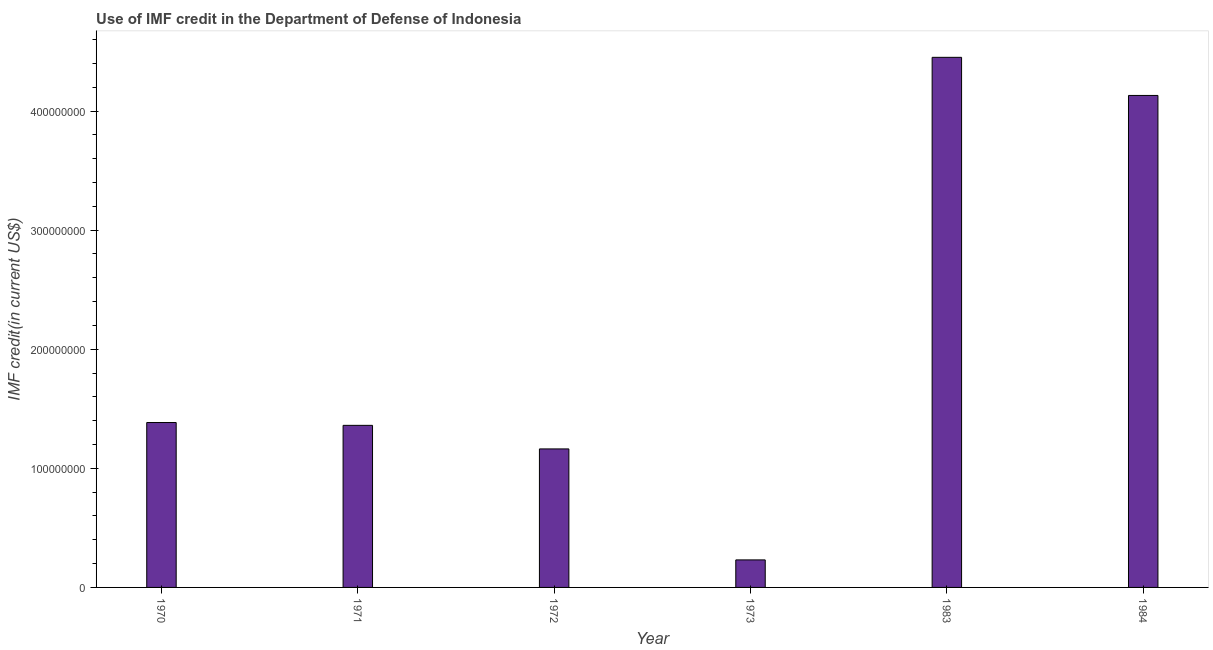Does the graph contain any zero values?
Your response must be concise. No. What is the title of the graph?
Your answer should be compact. Use of IMF credit in the Department of Defense of Indonesia. What is the label or title of the X-axis?
Your answer should be compact. Year. What is the label or title of the Y-axis?
Your answer should be very brief. IMF credit(in current US$). What is the use of imf credit in dod in 1970?
Make the answer very short. 1.38e+08. Across all years, what is the maximum use of imf credit in dod?
Make the answer very short. 4.45e+08. Across all years, what is the minimum use of imf credit in dod?
Provide a succinct answer. 2.31e+07. In which year was the use of imf credit in dod maximum?
Make the answer very short. 1983. In which year was the use of imf credit in dod minimum?
Offer a very short reply. 1973. What is the sum of the use of imf credit in dod?
Provide a succinct answer. 1.27e+09. What is the difference between the use of imf credit in dod in 1970 and 1983?
Make the answer very short. -3.07e+08. What is the average use of imf credit in dod per year?
Make the answer very short. 2.12e+08. What is the median use of imf credit in dod?
Provide a short and direct response. 1.37e+08. In how many years, is the use of imf credit in dod greater than 280000000 US$?
Make the answer very short. 2. What is the ratio of the use of imf credit in dod in 1971 to that in 1973?
Offer a terse response. 5.89. Is the use of imf credit in dod in 1970 less than that in 1971?
Provide a succinct answer. No. What is the difference between the highest and the second highest use of imf credit in dod?
Give a very brief answer. 3.20e+07. What is the difference between the highest and the lowest use of imf credit in dod?
Offer a terse response. 4.22e+08. How many bars are there?
Give a very brief answer. 6. What is the difference between two consecutive major ticks on the Y-axis?
Your answer should be compact. 1.00e+08. Are the values on the major ticks of Y-axis written in scientific E-notation?
Keep it short and to the point. No. What is the IMF credit(in current US$) of 1970?
Keep it short and to the point. 1.38e+08. What is the IMF credit(in current US$) in 1971?
Offer a very short reply. 1.36e+08. What is the IMF credit(in current US$) in 1972?
Offer a terse response. 1.16e+08. What is the IMF credit(in current US$) of 1973?
Your answer should be compact. 2.31e+07. What is the IMF credit(in current US$) of 1983?
Your answer should be compact. 4.45e+08. What is the IMF credit(in current US$) of 1984?
Give a very brief answer. 4.13e+08. What is the difference between the IMF credit(in current US$) in 1970 and 1971?
Ensure brevity in your answer.  2.37e+06. What is the difference between the IMF credit(in current US$) in 1970 and 1972?
Keep it short and to the point. 2.22e+07. What is the difference between the IMF credit(in current US$) in 1970 and 1973?
Offer a terse response. 1.15e+08. What is the difference between the IMF credit(in current US$) in 1970 and 1983?
Your answer should be very brief. -3.07e+08. What is the difference between the IMF credit(in current US$) in 1970 and 1984?
Your answer should be compact. -2.75e+08. What is the difference between the IMF credit(in current US$) in 1971 and 1972?
Keep it short and to the point. 1.98e+07. What is the difference between the IMF credit(in current US$) in 1971 and 1973?
Provide a succinct answer. 1.13e+08. What is the difference between the IMF credit(in current US$) in 1971 and 1983?
Your answer should be very brief. -3.09e+08. What is the difference between the IMF credit(in current US$) in 1971 and 1984?
Provide a short and direct response. -2.77e+08. What is the difference between the IMF credit(in current US$) in 1972 and 1973?
Your answer should be very brief. 9.32e+07. What is the difference between the IMF credit(in current US$) in 1972 and 1983?
Keep it short and to the point. -3.29e+08. What is the difference between the IMF credit(in current US$) in 1972 and 1984?
Offer a terse response. -2.97e+08. What is the difference between the IMF credit(in current US$) in 1973 and 1983?
Keep it short and to the point. -4.22e+08. What is the difference between the IMF credit(in current US$) in 1973 and 1984?
Offer a very short reply. -3.90e+08. What is the difference between the IMF credit(in current US$) in 1983 and 1984?
Give a very brief answer. 3.20e+07. What is the ratio of the IMF credit(in current US$) in 1970 to that in 1972?
Your answer should be very brief. 1.19. What is the ratio of the IMF credit(in current US$) in 1970 to that in 1973?
Your response must be concise. 5.99. What is the ratio of the IMF credit(in current US$) in 1970 to that in 1983?
Your answer should be compact. 0.31. What is the ratio of the IMF credit(in current US$) in 1970 to that in 1984?
Provide a succinct answer. 0.34. What is the ratio of the IMF credit(in current US$) in 1971 to that in 1972?
Your response must be concise. 1.17. What is the ratio of the IMF credit(in current US$) in 1971 to that in 1973?
Provide a short and direct response. 5.89. What is the ratio of the IMF credit(in current US$) in 1971 to that in 1983?
Offer a very short reply. 0.31. What is the ratio of the IMF credit(in current US$) in 1971 to that in 1984?
Ensure brevity in your answer.  0.33. What is the ratio of the IMF credit(in current US$) in 1972 to that in 1973?
Give a very brief answer. 5.03. What is the ratio of the IMF credit(in current US$) in 1972 to that in 1983?
Provide a short and direct response. 0.26. What is the ratio of the IMF credit(in current US$) in 1972 to that in 1984?
Offer a very short reply. 0.28. What is the ratio of the IMF credit(in current US$) in 1973 to that in 1983?
Offer a terse response. 0.05. What is the ratio of the IMF credit(in current US$) in 1973 to that in 1984?
Ensure brevity in your answer.  0.06. What is the ratio of the IMF credit(in current US$) in 1983 to that in 1984?
Offer a very short reply. 1.08. 